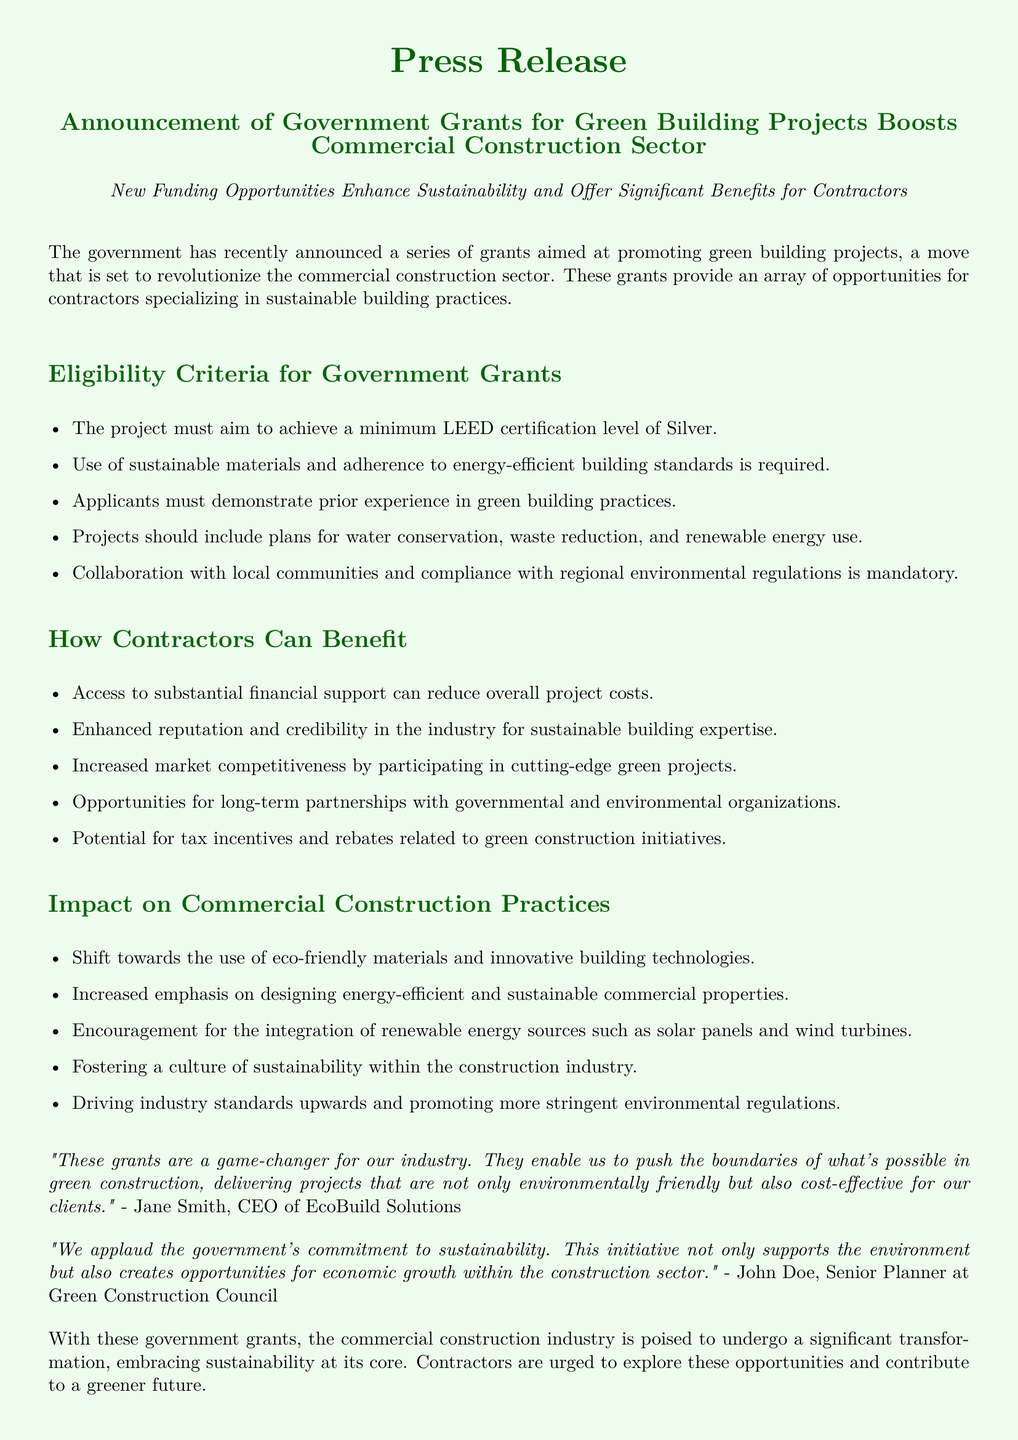What is the minimum LEED certification level required? The eligibility criteria specify that projects must aim to achieve a minimum LEED certification level of Silver.
Answer: Silver What type of support do contractors gain access to? Contractors can access substantial financial support, which is mentioned as a benefit in the document.
Answer: Financial support What must applicants demonstrate before applying? The document states that applicants must demonstrate prior experience in green building practices.
Answer: Prior experience Who is the CEO mentioned in the press release? The document quotes Jane Smith, who is identified as the CEO of EcoBuild Solutions.
Answer: Jane Smith What is a key impact on commercial construction practices? The press release notes that there will be an increased emphasis on designing energy-efficient and sustainable commercial properties.
Answer: Energy-efficient and sustainable properties What type of materials are encouraged for use in projects? The document indicates a shift towards the use of eco-friendly materials in commercial construction practices.
Answer: Eco-friendly materials What does the initiative create opportunities for? The last quote in the document highlights that the initiative creates opportunities for economic growth within the construction sector.
Answer: Economic growth What type of organizations can contractors form partnerships with? The press release mentions opportunities for long-term partnerships with governmental and environmental organizations.
Answer: Governmental and environmental organizations What is the color theme used in the press release? The document features a light green background and dark green text color theme, promoting the green initiative.
Answer: Light green and dark green 